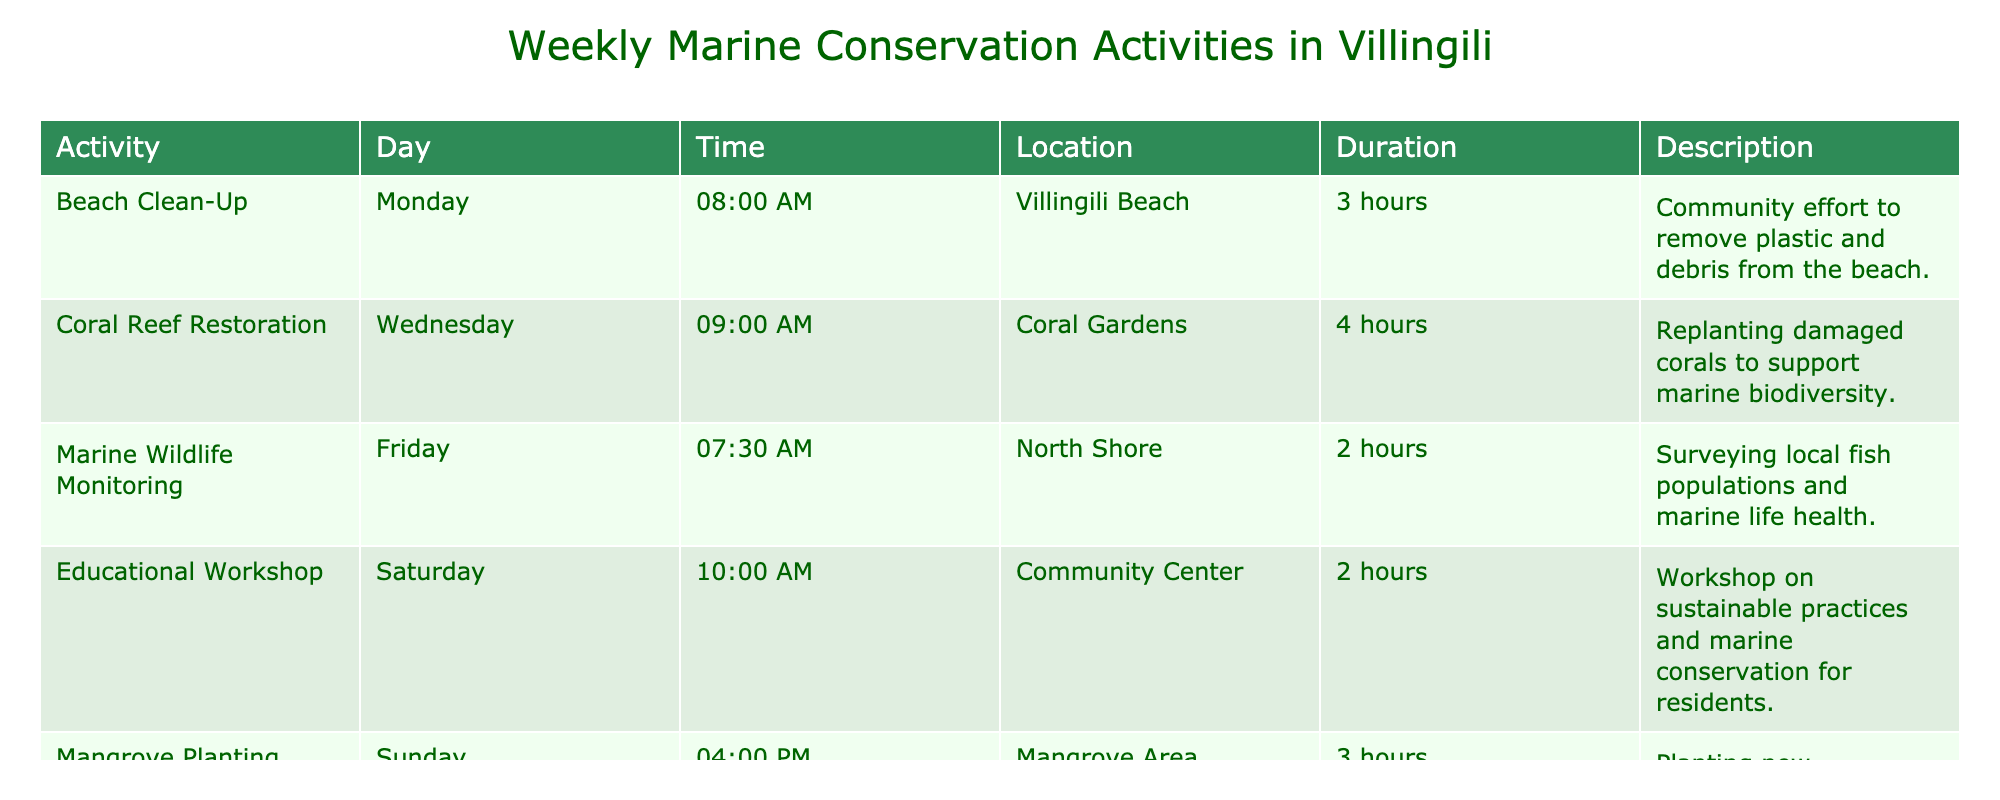What is the duration of the Beach Clean-Up activity? The Beach Clean-Up activity is listed in the table with a duration of 3 hours. It is directly stated in the Duration column for the relevant activity.
Answer: 3 hours On which day is the Coral Reef Restoration scheduled? The Coral Reef Restoration activity is scheduled for Wednesday, as indicated in the Day column corresponding to this activity.
Answer: Wednesday Is there a marine conservation activity on Tuesday? There are no activities scheduled on Tuesday according to the Day column of the table. All other days have at least one listed activity.
Answer: No What is the total duration of all marine conservation activities held on weekends (Saturday and Sunday)? The durations for Saturday and Sunday activities are 2 hours (Educational Workshop on Saturday) and 3 hours (Mangrove Planting on Sunday). Adding these gives 2 + 3 = 5 hours total for weekend activities.
Answer: 5 hours Which activity starts the earliest in the week? The Marine Wildlife Monitoring starts the earliest at 7:30 AM on Friday, according to the Time column. Since no activities are earlier in the week, it is the earliest overall.
Answer: Marine Wildlife Monitoring How many hours of marine conservation activities are scheduled in total for the week? By summing the durations from each activity: 3 (Beach Clean-Up) + 4 (Coral Reef Restoration) + 2 (Marine Wildlife Monitoring) + 2 (Educational Workshop) + 3 (Mangrove Planting) equals a total of 14 hours of activities scheduled throughout the week.
Answer: 14 hours Is the location for the Educational Workshop the Community Center? The Educational Workshop is indeed listed with the Community Center as its location, confirmed from the Location column for this entry in the table.
Answer: Yes Which activity involves monitoring marine wildlife? The activity titled Marine Wildlife Monitoring is specifically focused on surveying local fish populations and marine life health, as noted in the Description column.
Answer: Marine Wildlife Monitoring 